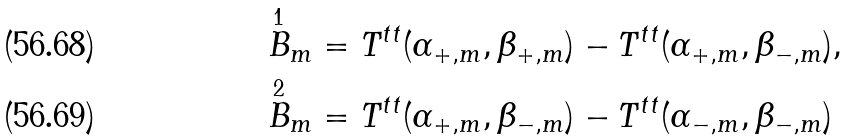Convert formula to latex. <formula><loc_0><loc_0><loc_500><loc_500>\overset { 1 } { B } _ { m } & = T ^ { t t } ( \alpha _ { + , m } , \beta _ { + , m } ) - T ^ { t t } ( \alpha _ { + , m } , \beta _ { - , m } ) , \\ \overset { 2 } { B } _ { m } & = T ^ { t t } ( \alpha _ { + , m } , \beta _ { - , m } ) - T ^ { t t } ( \alpha _ { - , m } , \beta _ { - , m } )</formula> 